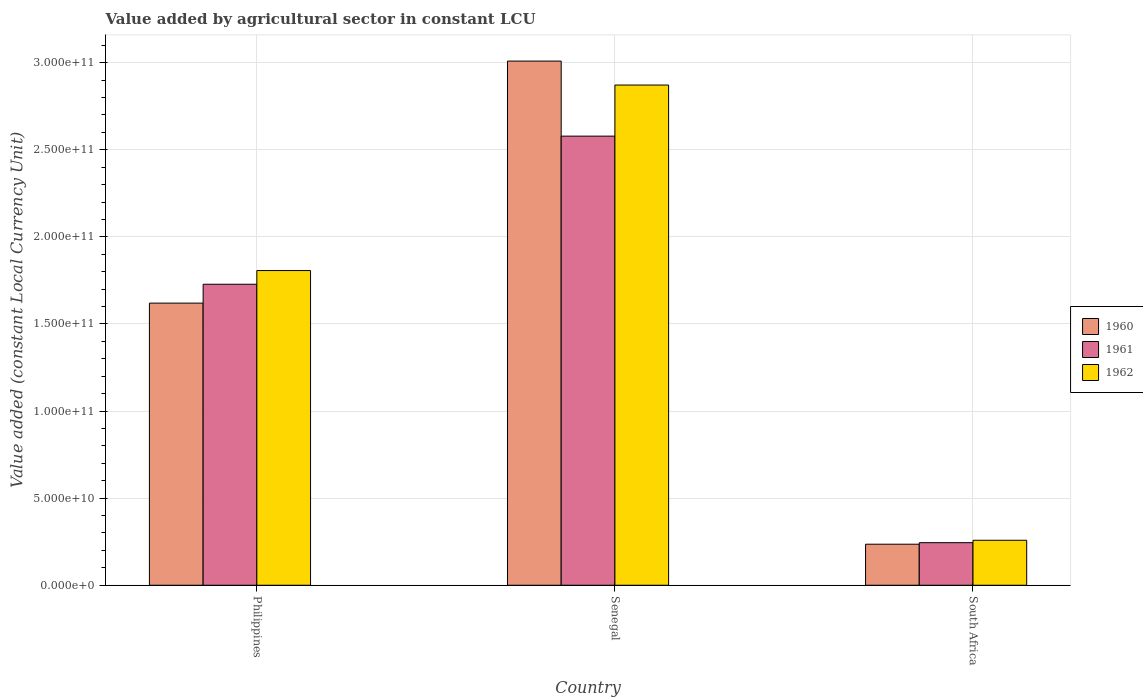How many bars are there on the 1st tick from the left?
Your answer should be compact. 3. How many bars are there on the 2nd tick from the right?
Your response must be concise. 3. What is the label of the 2nd group of bars from the left?
Ensure brevity in your answer.  Senegal. In how many cases, is the number of bars for a given country not equal to the number of legend labels?
Your response must be concise. 0. What is the value added by agricultural sector in 1962 in South Africa?
Your response must be concise. 2.58e+1. Across all countries, what is the maximum value added by agricultural sector in 1961?
Keep it short and to the point. 2.58e+11. Across all countries, what is the minimum value added by agricultural sector in 1961?
Provide a succinct answer. 2.44e+1. In which country was the value added by agricultural sector in 1961 maximum?
Give a very brief answer. Senegal. In which country was the value added by agricultural sector in 1960 minimum?
Give a very brief answer. South Africa. What is the total value added by agricultural sector in 1962 in the graph?
Your response must be concise. 4.94e+11. What is the difference between the value added by agricultural sector in 1960 in Senegal and that in South Africa?
Your answer should be very brief. 2.77e+11. What is the difference between the value added by agricultural sector in 1961 in Senegal and the value added by agricultural sector in 1962 in South Africa?
Your answer should be very brief. 2.32e+11. What is the average value added by agricultural sector in 1962 per country?
Your answer should be compact. 1.65e+11. What is the difference between the value added by agricultural sector of/in 1962 and value added by agricultural sector of/in 1960 in Philippines?
Your response must be concise. 1.87e+1. In how many countries, is the value added by agricultural sector in 1960 greater than 40000000000 LCU?
Your answer should be very brief. 2. What is the ratio of the value added by agricultural sector in 1962 in Senegal to that in South Africa?
Offer a terse response. 11.12. What is the difference between the highest and the second highest value added by agricultural sector in 1961?
Offer a very short reply. 2.33e+11. What is the difference between the highest and the lowest value added by agricultural sector in 1961?
Make the answer very short. 2.33e+11. In how many countries, is the value added by agricultural sector in 1960 greater than the average value added by agricultural sector in 1960 taken over all countries?
Your answer should be very brief. 1. Is the sum of the value added by agricultural sector in 1961 in Philippines and South Africa greater than the maximum value added by agricultural sector in 1962 across all countries?
Ensure brevity in your answer.  No. What does the 3rd bar from the right in Senegal represents?
Offer a very short reply. 1960. Is it the case that in every country, the sum of the value added by agricultural sector in 1962 and value added by agricultural sector in 1960 is greater than the value added by agricultural sector in 1961?
Offer a very short reply. Yes. How many countries are there in the graph?
Your response must be concise. 3. Are the values on the major ticks of Y-axis written in scientific E-notation?
Provide a short and direct response. Yes. How many legend labels are there?
Make the answer very short. 3. How are the legend labels stacked?
Your response must be concise. Vertical. What is the title of the graph?
Provide a succinct answer. Value added by agricultural sector in constant LCU. What is the label or title of the X-axis?
Give a very brief answer. Country. What is the label or title of the Y-axis?
Keep it short and to the point. Value added (constant Local Currency Unit). What is the Value added (constant Local Currency Unit) of 1960 in Philippines?
Make the answer very short. 1.62e+11. What is the Value added (constant Local Currency Unit) of 1961 in Philippines?
Make the answer very short. 1.73e+11. What is the Value added (constant Local Currency Unit) in 1962 in Philippines?
Offer a very short reply. 1.81e+11. What is the Value added (constant Local Currency Unit) in 1960 in Senegal?
Provide a short and direct response. 3.01e+11. What is the Value added (constant Local Currency Unit) of 1961 in Senegal?
Provide a succinct answer. 2.58e+11. What is the Value added (constant Local Currency Unit) of 1962 in Senegal?
Provide a succinct answer. 2.87e+11. What is the Value added (constant Local Currency Unit) in 1960 in South Africa?
Provide a succinct answer. 2.36e+1. What is the Value added (constant Local Currency Unit) of 1961 in South Africa?
Your answer should be very brief. 2.44e+1. What is the Value added (constant Local Currency Unit) in 1962 in South Africa?
Provide a short and direct response. 2.58e+1. Across all countries, what is the maximum Value added (constant Local Currency Unit) of 1960?
Your answer should be very brief. 3.01e+11. Across all countries, what is the maximum Value added (constant Local Currency Unit) in 1961?
Keep it short and to the point. 2.58e+11. Across all countries, what is the maximum Value added (constant Local Currency Unit) of 1962?
Make the answer very short. 2.87e+11. Across all countries, what is the minimum Value added (constant Local Currency Unit) of 1960?
Your answer should be compact. 2.36e+1. Across all countries, what is the minimum Value added (constant Local Currency Unit) in 1961?
Offer a terse response. 2.44e+1. Across all countries, what is the minimum Value added (constant Local Currency Unit) of 1962?
Offer a very short reply. 2.58e+1. What is the total Value added (constant Local Currency Unit) in 1960 in the graph?
Your answer should be very brief. 4.86e+11. What is the total Value added (constant Local Currency Unit) of 1961 in the graph?
Give a very brief answer. 4.55e+11. What is the total Value added (constant Local Currency Unit) of 1962 in the graph?
Your response must be concise. 4.94e+11. What is the difference between the Value added (constant Local Currency Unit) in 1960 in Philippines and that in Senegal?
Your response must be concise. -1.39e+11. What is the difference between the Value added (constant Local Currency Unit) of 1961 in Philippines and that in Senegal?
Offer a very short reply. -8.50e+1. What is the difference between the Value added (constant Local Currency Unit) of 1962 in Philippines and that in Senegal?
Your answer should be very brief. -1.07e+11. What is the difference between the Value added (constant Local Currency Unit) of 1960 in Philippines and that in South Africa?
Your response must be concise. 1.38e+11. What is the difference between the Value added (constant Local Currency Unit) in 1961 in Philippines and that in South Africa?
Ensure brevity in your answer.  1.48e+11. What is the difference between the Value added (constant Local Currency Unit) of 1962 in Philippines and that in South Africa?
Your answer should be very brief. 1.55e+11. What is the difference between the Value added (constant Local Currency Unit) in 1960 in Senegal and that in South Africa?
Your answer should be very brief. 2.77e+11. What is the difference between the Value added (constant Local Currency Unit) of 1961 in Senegal and that in South Africa?
Your answer should be compact. 2.33e+11. What is the difference between the Value added (constant Local Currency Unit) in 1962 in Senegal and that in South Africa?
Your answer should be compact. 2.61e+11. What is the difference between the Value added (constant Local Currency Unit) in 1960 in Philippines and the Value added (constant Local Currency Unit) in 1961 in Senegal?
Make the answer very short. -9.59e+1. What is the difference between the Value added (constant Local Currency Unit) of 1960 in Philippines and the Value added (constant Local Currency Unit) of 1962 in Senegal?
Your answer should be very brief. -1.25e+11. What is the difference between the Value added (constant Local Currency Unit) in 1961 in Philippines and the Value added (constant Local Currency Unit) in 1962 in Senegal?
Offer a terse response. -1.14e+11. What is the difference between the Value added (constant Local Currency Unit) of 1960 in Philippines and the Value added (constant Local Currency Unit) of 1961 in South Africa?
Keep it short and to the point. 1.38e+11. What is the difference between the Value added (constant Local Currency Unit) in 1960 in Philippines and the Value added (constant Local Currency Unit) in 1962 in South Africa?
Make the answer very short. 1.36e+11. What is the difference between the Value added (constant Local Currency Unit) in 1961 in Philippines and the Value added (constant Local Currency Unit) in 1962 in South Africa?
Offer a terse response. 1.47e+11. What is the difference between the Value added (constant Local Currency Unit) of 1960 in Senegal and the Value added (constant Local Currency Unit) of 1961 in South Africa?
Your answer should be very brief. 2.77e+11. What is the difference between the Value added (constant Local Currency Unit) in 1960 in Senegal and the Value added (constant Local Currency Unit) in 1962 in South Africa?
Your answer should be very brief. 2.75e+11. What is the difference between the Value added (constant Local Currency Unit) of 1961 in Senegal and the Value added (constant Local Currency Unit) of 1962 in South Africa?
Offer a terse response. 2.32e+11. What is the average Value added (constant Local Currency Unit) in 1960 per country?
Offer a terse response. 1.62e+11. What is the average Value added (constant Local Currency Unit) in 1961 per country?
Your response must be concise. 1.52e+11. What is the average Value added (constant Local Currency Unit) in 1962 per country?
Provide a short and direct response. 1.65e+11. What is the difference between the Value added (constant Local Currency Unit) in 1960 and Value added (constant Local Currency Unit) in 1961 in Philippines?
Give a very brief answer. -1.08e+1. What is the difference between the Value added (constant Local Currency Unit) in 1960 and Value added (constant Local Currency Unit) in 1962 in Philippines?
Offer a terse response. -1.87e+1. What is the difference between the Value added (constant Local Currency Unit) in 1961 and Value added (constant Local Currency Unit) in 1962 in Philippines?
Provide a short and direct response. -7.86e+09. What is the difference between the Value added (constant Local Currency Unit) in 1960 and Value added (constant Local Currency Unit) in 1961 in Senegal?
Your answer should be compact. 4.31e+1. What is the difference between the Value added (constant Local Currency Unit) of 1960 and Value added (constant Local Currency Unit) of 1962 in Senegal?
Your answer should be very brief. 1.38e+1. What is the difference between the Value added (constant Local Currency Unit) of 1961 and Value added (constant Local Currency Unit) of 1962 in Senegal?
Offer a terse response. -2.93e+1. What is the difference between the Value added (constant Local Currency Unit) in 1960 and Value added (constant Local Currency Unit) in 1961 in South Africa?
Ensure brevity in your answer.  -8.75e+08. What is the difference between the Value added (constant Local Currency Unit) of 1960 and Value added (constant Local Currency Unit) of 1962 in South Africa?
Provide a short and direct response. -2.26e+09. What is the difference between the Value added (constant Local Currency Unit) of 1961 and Value added (constant Local Currency Unit) of 1962 in South Africa?
Your response must be concise. -1.39e+09. What is the ratio of the Value added (constant Local Currency Unit) of 1960 in Philippines to that in Senegal?
Give a very brief answer. 0.54. What is the ratio of the Value added (constant Local Currency Unit) in 1961 in Philippines to that in Senegal?
Keep it short and to the point. 0.67. What is the ratio of the Value added (constant Local Currency Unit) of 1962 in Philippines to that in Senegal?
Provide a succinct answer. 0.63. What is the ratio of the Value added (constant Local Currency Unit) of 1960 in Philippines to that in South Africa?
Give a very brief answer. 6.88. What is the ratio of the Value added (constant Local Currency Unit) in 1961 in Philippines to that in South Africa?
Offer a terse response. 7.07. What is the ratio of the Value added (constant Local Currency Unit) in 1962 in Philippines to that in South Africa?
Provide a short and direct response. 7. What is the ratio of the Value added (constant Local Currency Unit) of 1960 in Senegal to that in South Africa?
Provide a succinct answer. 12.77. What is the ratio of the Value added (constant Local Currency Unit) of 1961 in Senegal to that in South Africa?
Make the answer very short. 10.55. What is the ratio of the Value added (constant Local Currency Unit) in 1962 in Senegal to that in South Africa?
Keep it short and to the point. 11.12. What is the difference between the highest and the second highest Value added (constant Local Currency Unit) in 1960?
Provide a succinct answer. 1.39e+11. What is the difference between the highest and the second highest Value added (constant Local Currency Unit) of 1961?
Give a very brief answer. 8.50e+1. What is the difference between the highest and the second highest Value added (constant Local Currency Unit) of 1962?
Keep it short and to the point. 1.07e+11. What is the difference between the highest and the lowest Value added (constant Local Currency Unit) of 1960?
Give a very brief answer. 2.77e+11. What is the difference between the highest and the lowest Value added (constant Local Currency Unit) of 1961?
Your answer should be very brief. 2.33e+11. What is the difference between the highest and the lowest Value added (constant Local Currency Unit) in 1962?
Ensure brevity in your answer.  2.61e+11. 